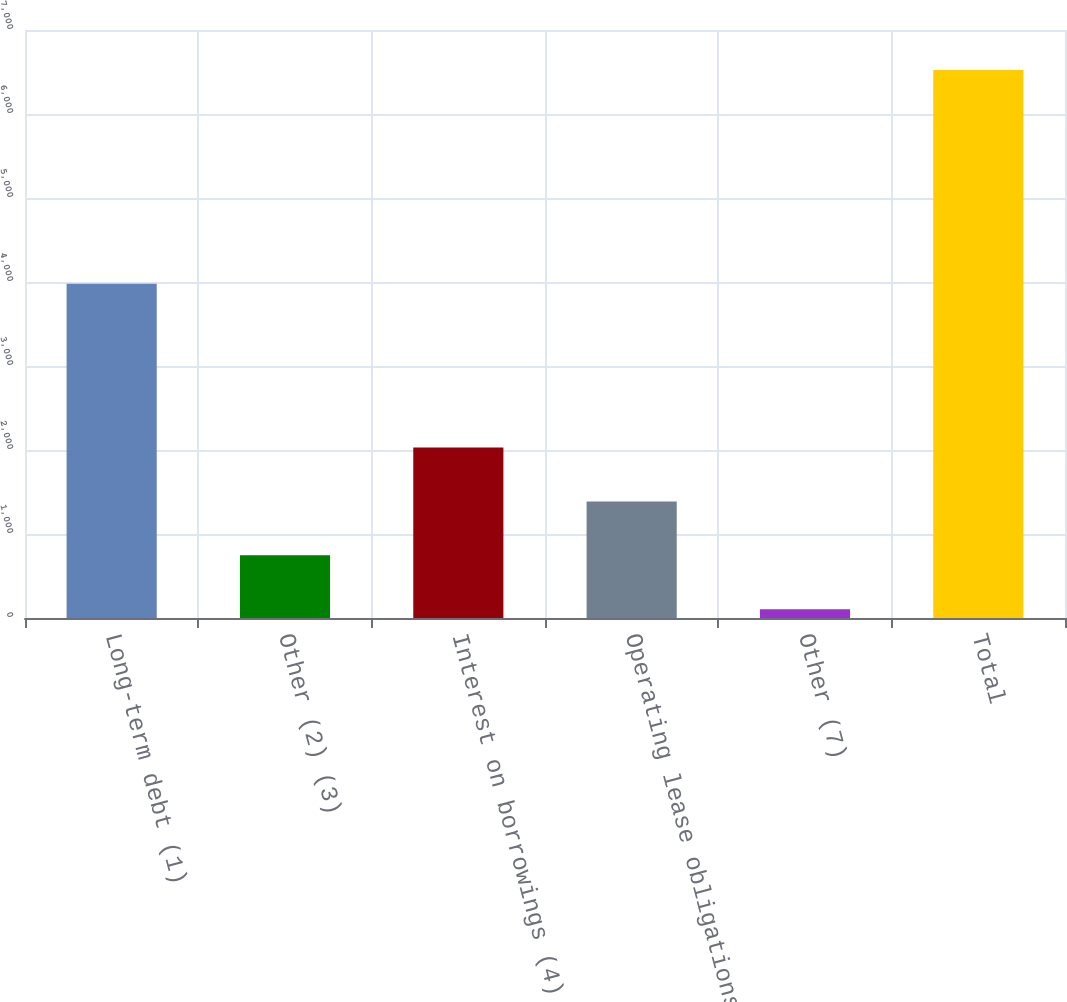<chart> <loc_0><loc_0><loc_500><loc_500><bar_chart><fcel>Long-term debt (1)<fcel>Other (2) (3)<fcel>Interest on borrowings (4)<fcel>Operating lease obligations<fcel>Other (7)<fcel>Total<nl><fcel>3980<fcel>746<fcel>2030<fcel>1388<fcel>104<fcel>6524<nl></chart> 